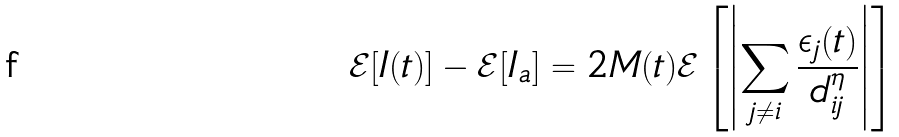<formula> <loc_0><loc_0><loc_500><loc_500>\mathcal { E } [ I ( t ) ] - \mathcal { E } [ I _ { a } ] = 2 M ( t ) \mathcal { E } \left [ \left | \sum _ { j \neq i } \frac { \epsilon _ { j } ( t ) } { d _ { i j } ^ { \eta } } \right | \right ]</formula> 